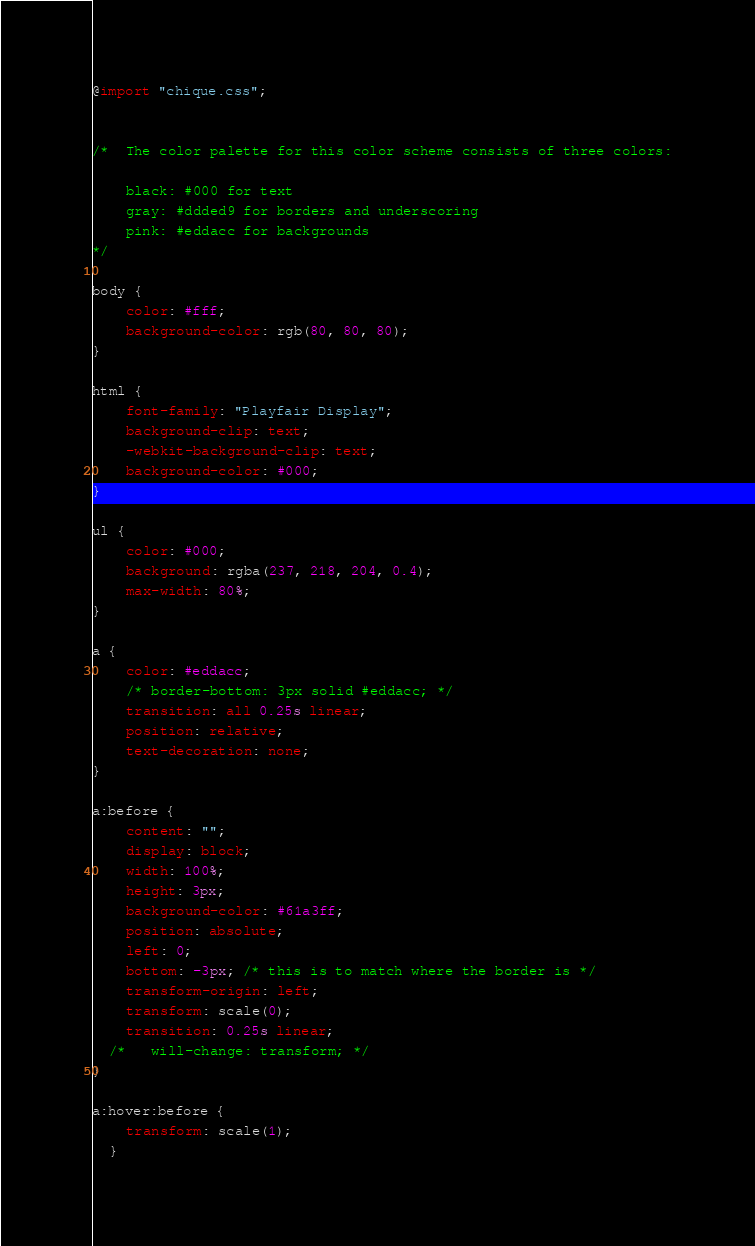Convert code to text. <code><loc_0><loc_0><loc_500><loc_500><_CSS_>
@import "chique.css";


/*  The color palette for this color scheme consists of three colors:

    black: #000 for text
    gray: #ddded9 for borders and underscoring
    pink: #eddacc for backgrounds
*/

body {
    color: #fff;
    background-color: rgb(80, 80, 80);
}

html {
    font-family: "Playfair Display";
    background-clip: text;
    -webkit-background-clip: text;
    background-color: #000;
}

ul {
    color: #000;
    background: rgba(237, 218, 204, 0.4);
    max-width: 80%;
}

a {
    color: #eddacc;
    /* border-bottom: 3px solid #eddacc; */
    transition: all 0.25s linear;
    position: relative;
    text-decoration: none;
}

a:before {
    content: "";
    display: block;
    width: 100%;
    height: 3px;
    background-color: #61a3ff;
    position: absolute;
    left: 0;
    bottom: -3px; /* this is to match where the border is */
    transform-origin: left; 
    transform: scale(0);
    transition: 0.25s linear;
  /*   will-change: transform; */
}

a:hover:before {
    transform: scale(1);
  }</code> 